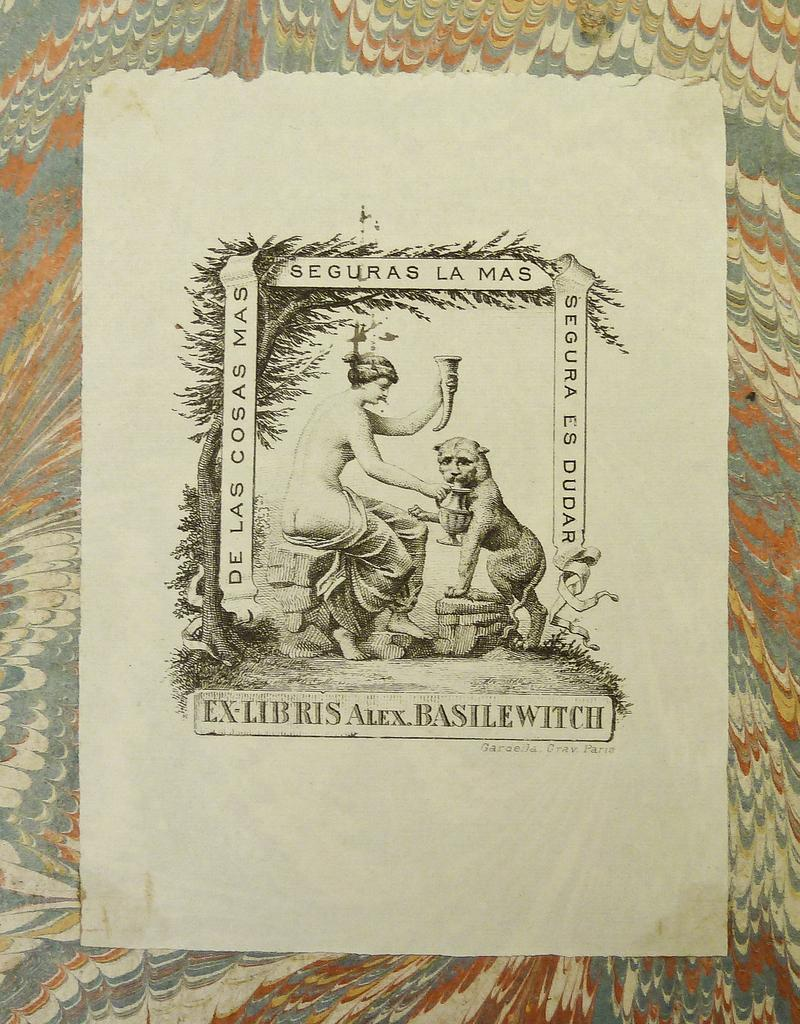<image>
Relay a brief, clear account of the picture shown. a poster with words De Las cosas Mas has a woman and lion on it 